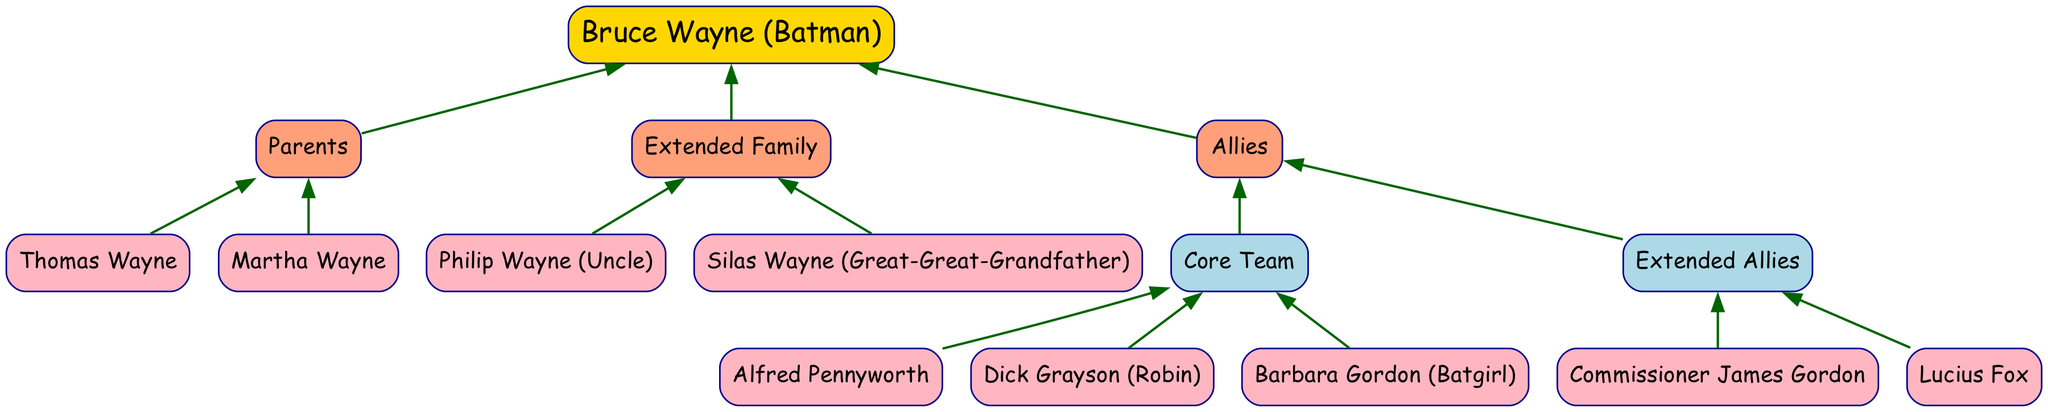What is the name of Batman's core ally? The diagram shows that Batman's core allies include Alfred Pennyworth, Dick Grayson (Robin), and Barbara Gordon (Batgirl). Thus, any one of these names can be considered a core ally of Batman.
Answer: Alfred Pennyworth How many parents does Bruce Wayne have? According to the diagram, Bruce Wayne has two parents listed: Thomas Wayne and Martha Wayne. Therefore, the answer is the number of these individuals.
Answer: 2 Who is Bruce Wayne's uncle? In the section labeled "Extended Family," the uncle listed under Bruce Wayne's family is Philip Wayne. The diagram points directly to this relationship.
Answer: Philip Wayne Which ally is associated with law enforcement? The diagram shows Commissioner James Gordon as part of the Extended Allies section under Batman's allies, indicating his strong association with law enforcement.
Answer: Commissioner James Gordon What is the relationship between Martha Wayne and Bruce Wayne? The diagram clearly shows that Martha Wayne is a direct parent of Bruce Wayne, indicating a mother-son relationship.
Answer: Mother Who are the members of the core team of allies? The diagram explicitly lists Alfred Pennyworth, Dick Grayson (Robin), and Barbara Gordon (Batgirl) in the Core Team section, identifying them as Batman's key allies. The answer reflects these three individuals collectively.
Answer: Alfred Pennyworth, Dick Grayson (Robin), Barbara Gordon (Batgirl) How many extended allies are mentioned in the diagram? The Extended Allies mentioned in the diagram include two individuals: Commissioner James Gordon and Lucius Fox. Therefore, counting these, we find the total number.
Answer: 2 What is the relationship of Silas Wayne to Bruce Wayne? The diagram specifies Silas Wayne under the Extended Family section, indicating he is Bruce Wayne's great-great-grandfather, showing a generational lineage.
Answer: Great-great-grandfather Which family member is not a blood relative? The diagram indicates that Alfred Pennyworth is a core ally and not a blood relative of Bruce Wayne, rather serving in a guardian and ally capacity.
Answer: Alfred Pennyworth 